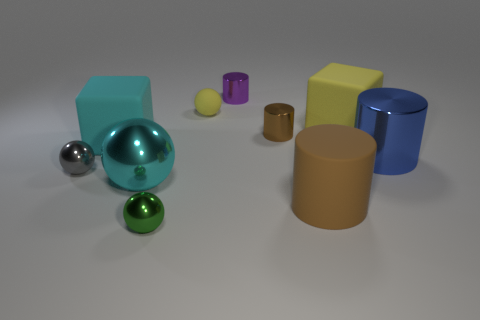Subtract all small brown cylinders. How many cylinders are left? 3 Subtract all cyan blocks. How many blocks are left? 1 Subtract all cylinders. How many objects are left? 6 Subtract 4 cylinders. How many cylinders are left? 0 Subtract 0 blue blocks. How many objects are left? 10 Subtract all yellow balls. Subtract all yellow blocks. How many balls are left? 3 Subtract all blue cylinders. How many cyan spheres are left? 1 Subtract all yellow rubber balls. Subtract all yellow rubber cubes. How many objects are left? 8 Add 3 small rubber things. How many small rubber things are left? 4 Add 1 brown rubber cylinders. How many brown rubber cylinders exist? 2 